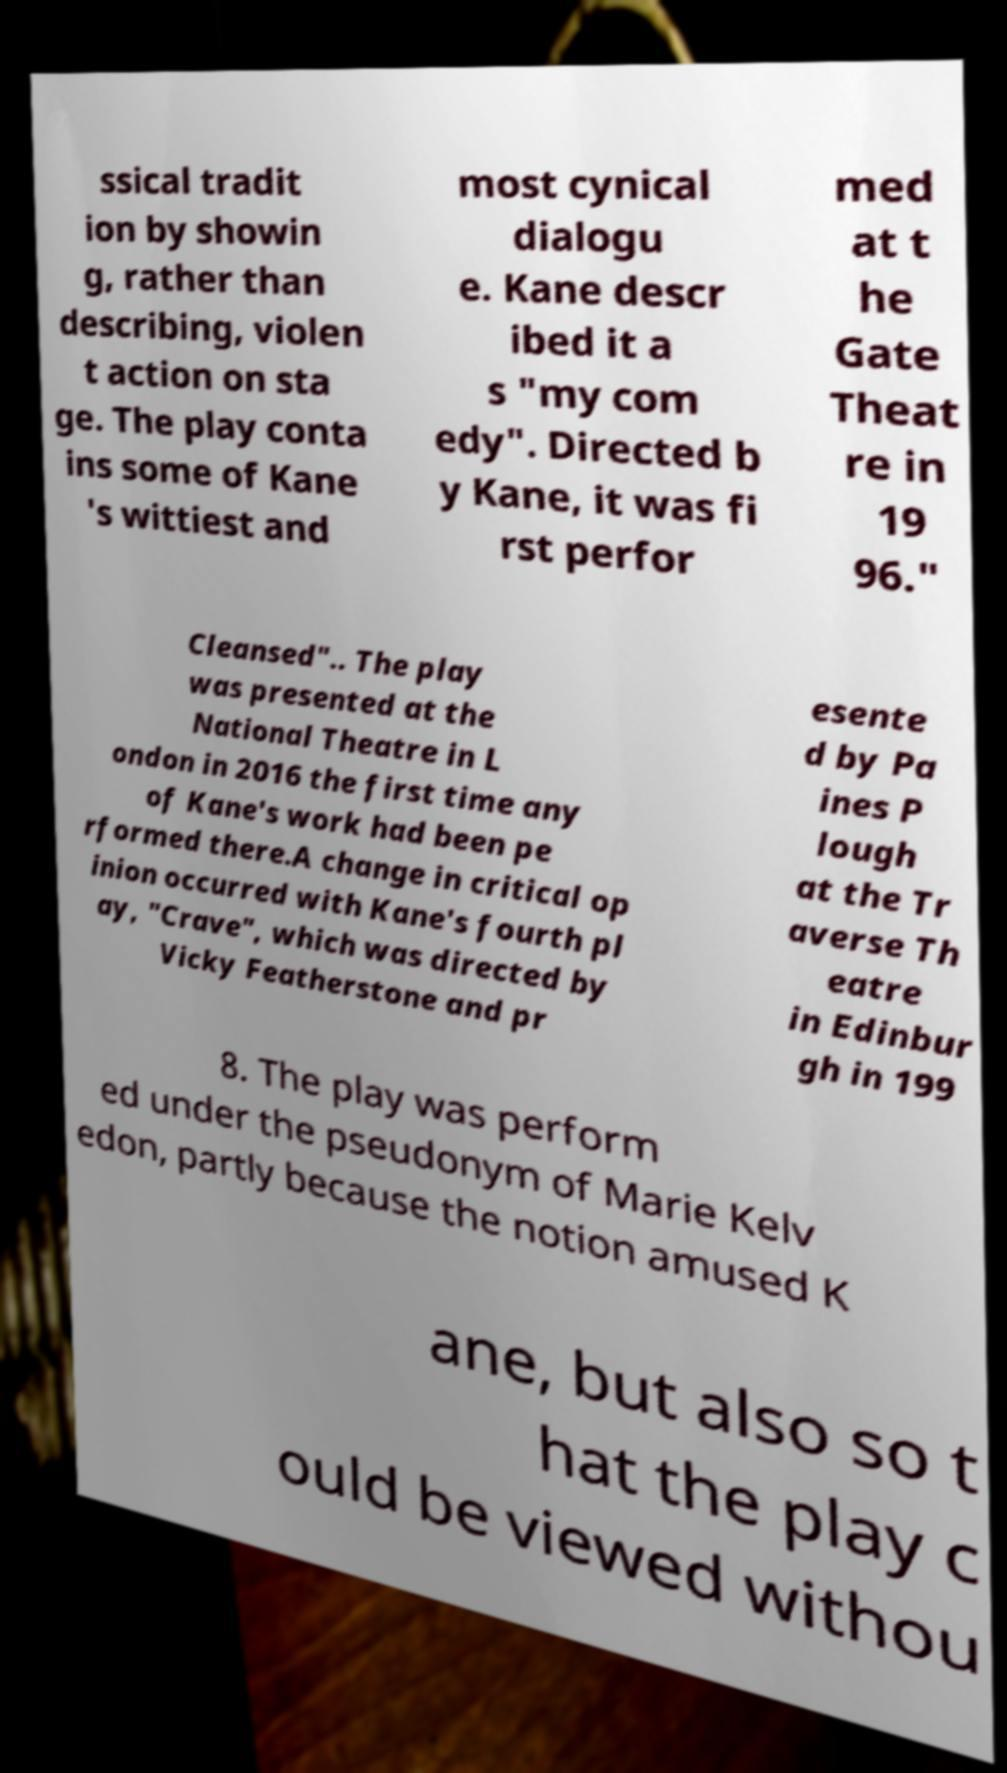What messages or text are displayed in this image? I need them in a readable, typed format. ssical tradit ion by showin g, rather than describing, violen t action on sta ge. The play conta ins some of Kane 's wittiest and most cynical dialogu e. Kane descr ibed it a s "my com edy". Directed b y Kane, it was fi rst perfor med at t he Gate Theat re in 19 96." Cleansed".. The play was presented at the National Theatre in L ondon in 2016 the first time any of Kane's work had been pe rformed there.A change in critical op inion occurred with Kane's fourth pl ay, "Crave", which was directed by Vicky Featherstone and pr esente d by Pa ines P lough at the Tr averse Th eatre in Edinbur gh in 199 8. The play was perform ed under the pseudonym of Marie Kelv edon, partly because the notion amused K ane, but also so t hat the play c ould be viewed withou 